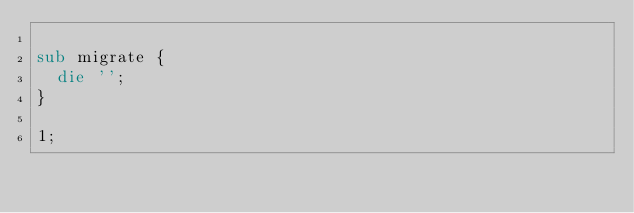<code> <loc_0><loc_0><loc_500><loc_500><_Perl_>
sub migrate {
  die '';
}

1;
</code> 